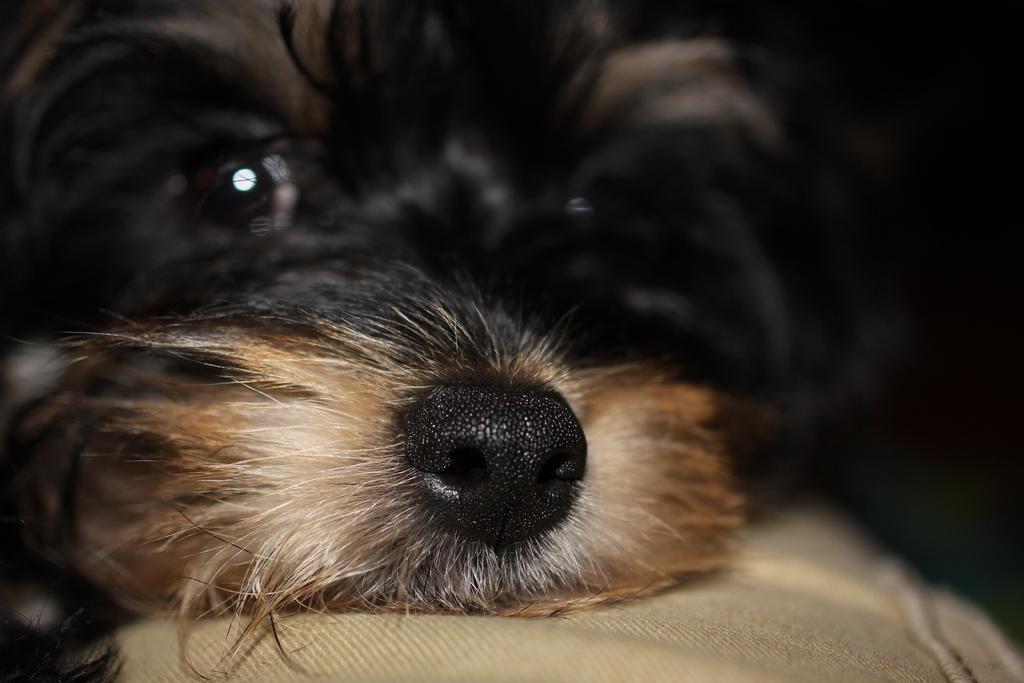In one or two sentences, can you explain what this image depicts? In this image we can see a dog on the surface. 